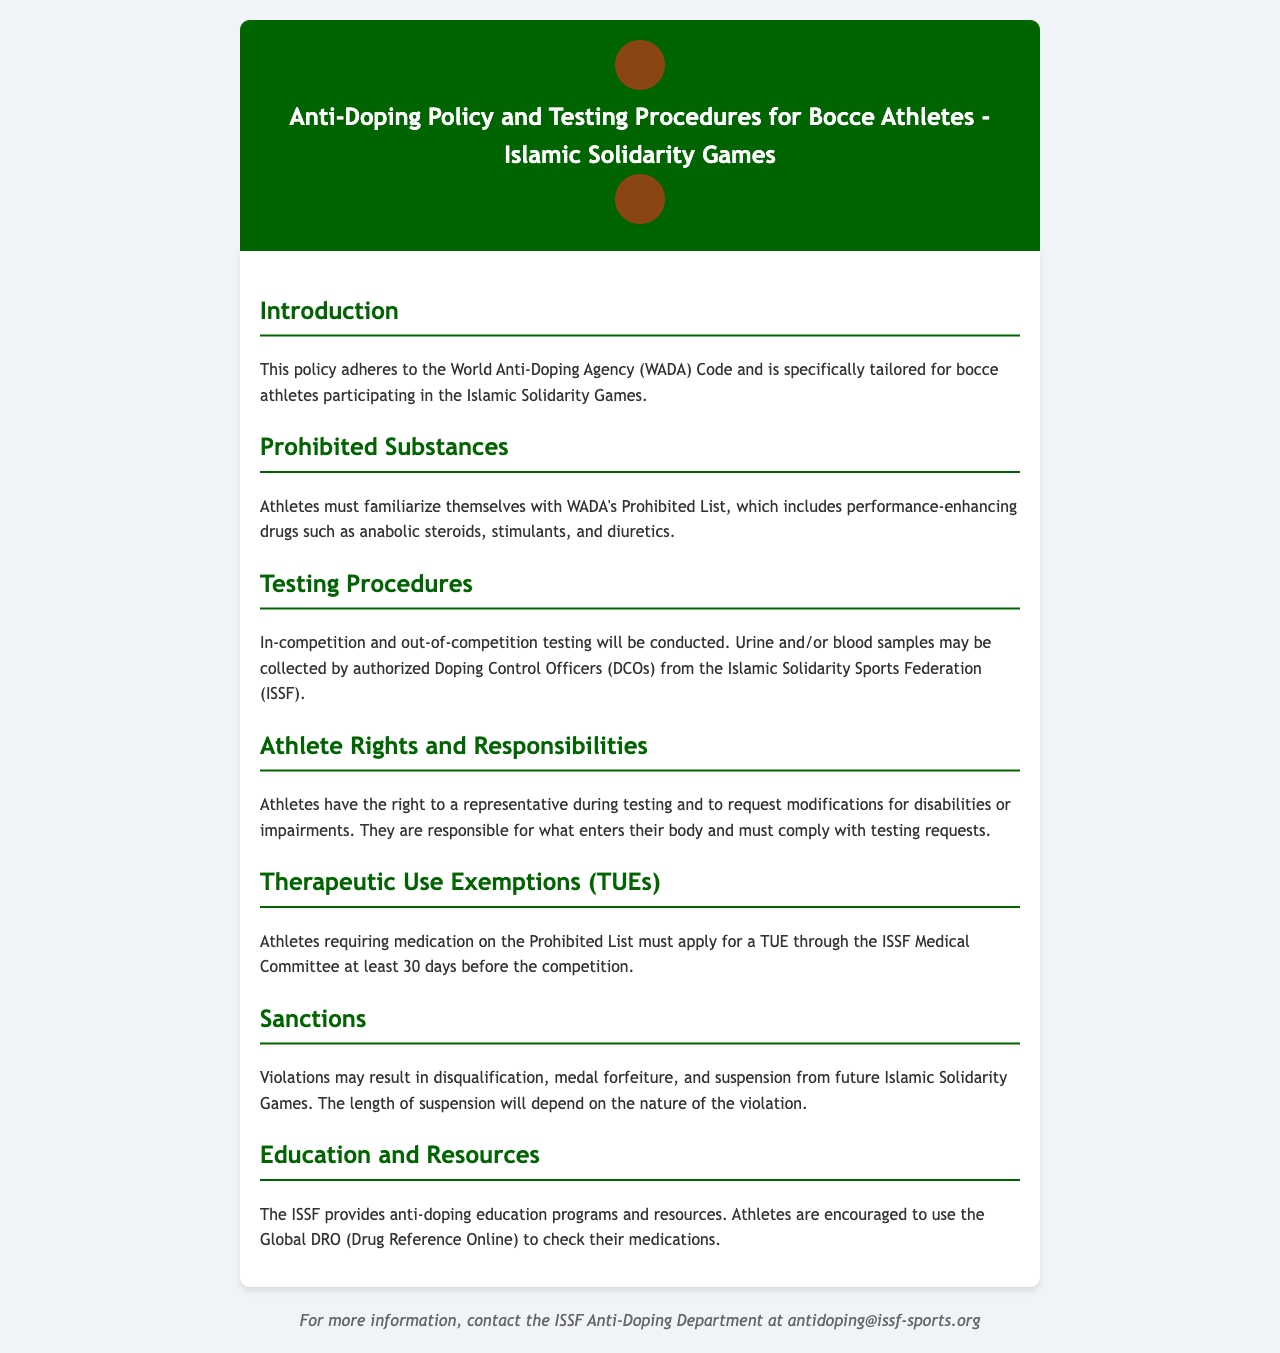What is the policy based on? The policy adheres to the World Anti-Doping Agency Code, specifically tailored for bocce athletes participating in the Islamic Solidarity Games.
Answer: WADA Code What substances are athletes required to familiarize themselves with? Athletes must familiarize themselves with WADA's Prohibited List, which includes performance-enhancing drugs.
Answer: Prohibited List What type of samples may be collected during testing? Urine and/or blood samples may be collected by authorized Doping Control Officers.
Answer: Urine and blood How many days in advance must athletes apply for a TUE? Athletes must apply for a Therapeutic Use Exemption a minimum of 30 days before the competition.
Answer: 30 days What can result from violations of the anti-doping policy? Violations may result in disqualification, medal forfeiture, and suspension from future Islamic Solidarity Games.
Answer: Disqualification What does ISSF provide to aid in understanding anti-doping policies? The ISSF provides anti-doping education programs and resources.
Answer: Education programs What rights do athletes have during testing? Athletes have the right to a representative during testing.
Answer: Representative What determines the length of suspension for violations? The length of suspension will depend on the nature of the violation.
Answer: Nature of the violation What online resource can athletes use to check their medications? Athletes are encouraged to use the Global DRO (Drug Reference Online).
Answer: Global DRO 